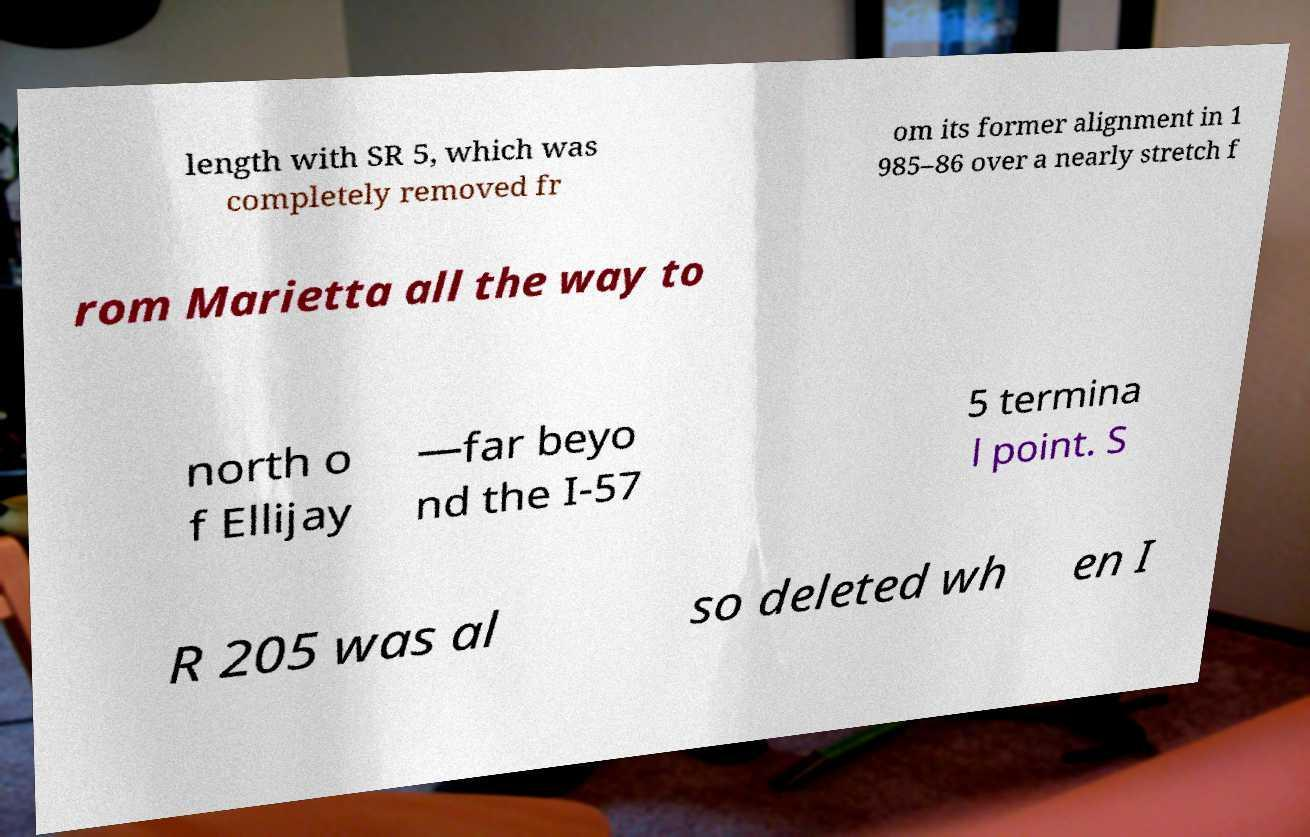There's text embedded in this image that I need extracted. Can you transcribe it verbatim? length with SR 5, which was completely removed fr om its former alignment in 1 985–86 over a nearly stretch f rom Marietta all the way to north o f Ellijay —far beyo nd the I-57 5 termina l point. S R 205 was al so deleted wh en I 